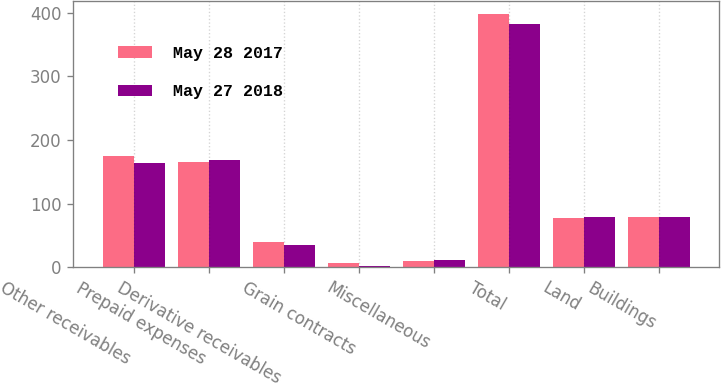Convert chart to OTSL. <chart><loc_0><loc_0><loc_500><loc_500><stacked_bar_chart><ecel><fcel>Other receivables<fcel>Prepaid expenses<fcel>Derivative receivables<fcel>Grain contracts<fcel>Miscellaneous<fcel>Total<fcel>Land<fcel>Buildings<nl><fcel>May 28 2017<fcel>174.4<fcel>165.6<fcel>40.5<fcel>7.1<fcel>10.7<fcel>398.3<fcel>77.7<fcel>78.75<nl><fcel>May 27 2018<fcel>163.7<fcel>168.9<fcel>35<fcel>2.7<fcel>11.3<fcel>381.6<fcel>79.8<fcel>78.75<nl></chart> 